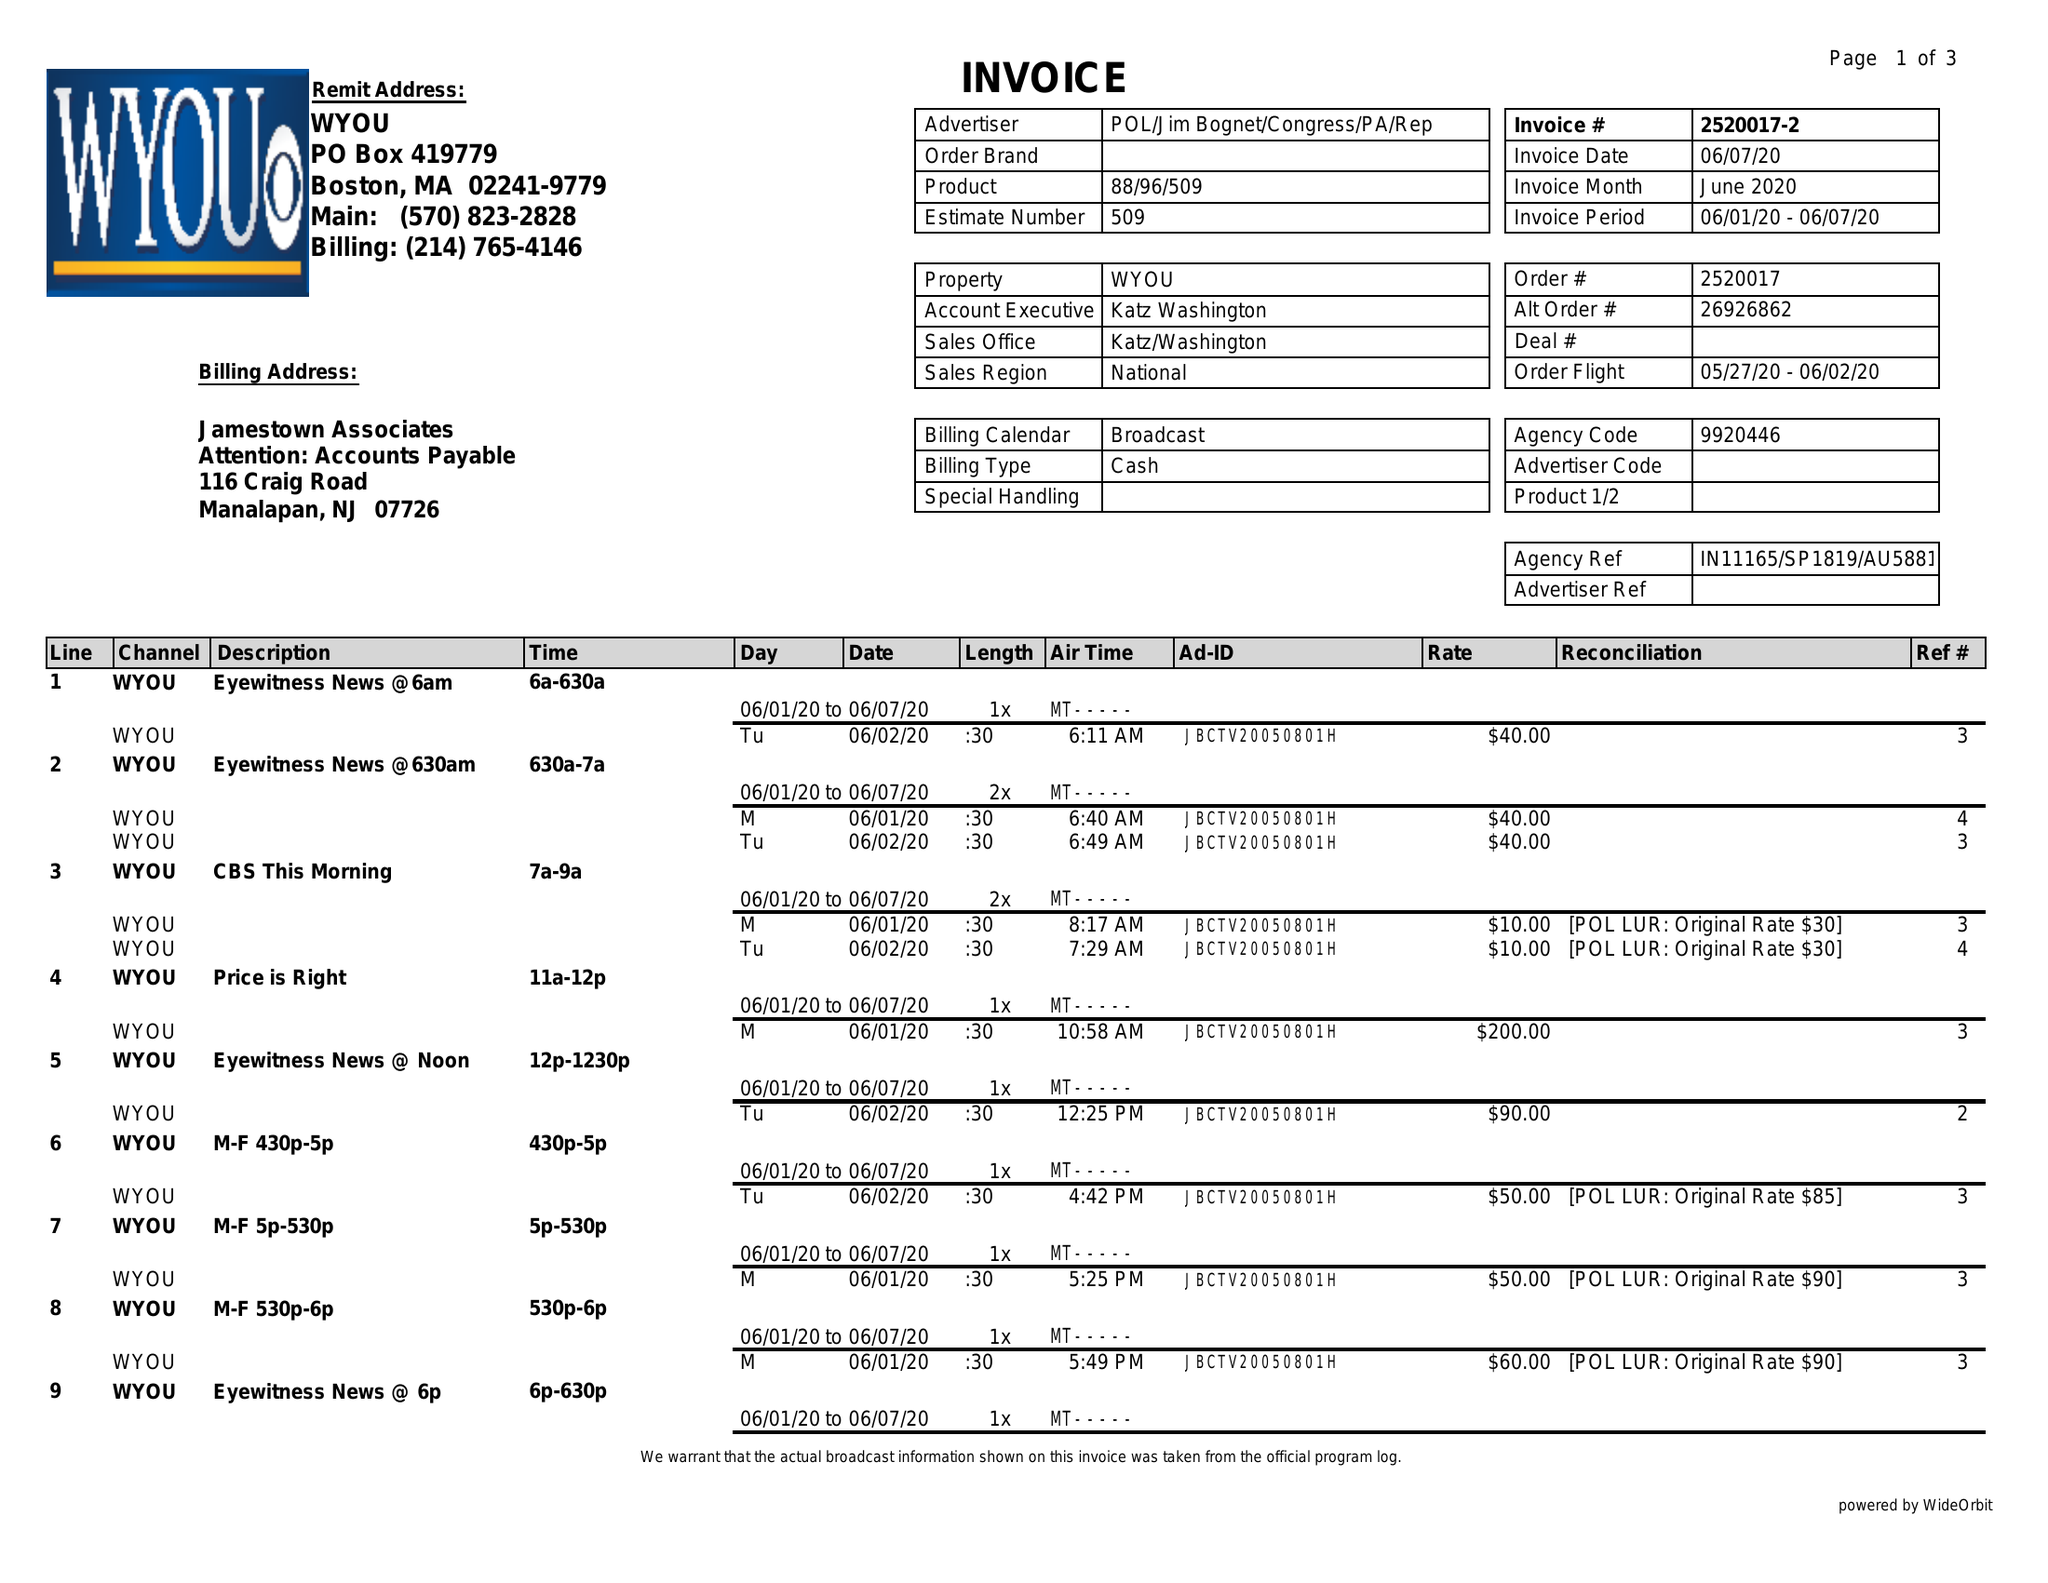What is the value for the flight_from?
Answer the question using a single word or phrase. 05/27/20 